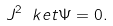<formula> <loc_0><loc_0><loc_500><loc_500>J ^ { 2 } \ k e t { \Psi } = 0 .</formula> 